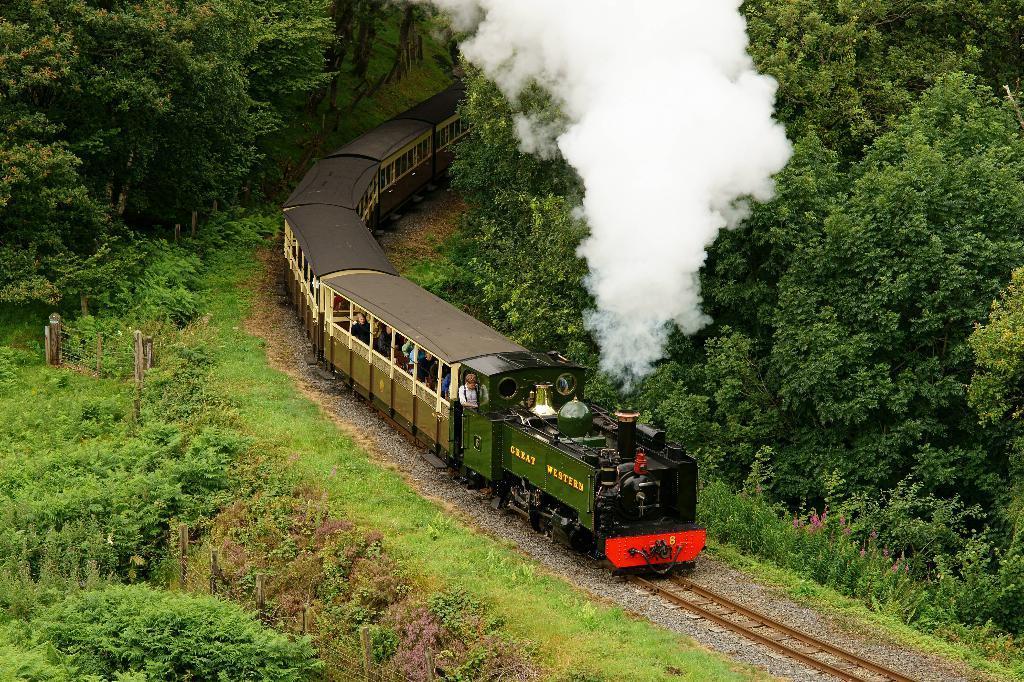Describe this image in one or two sentences. In this image we can see a group of people in a train which is on the track. We can also see some stones, grass, a fence, plants, a group of trees and the smoke. 